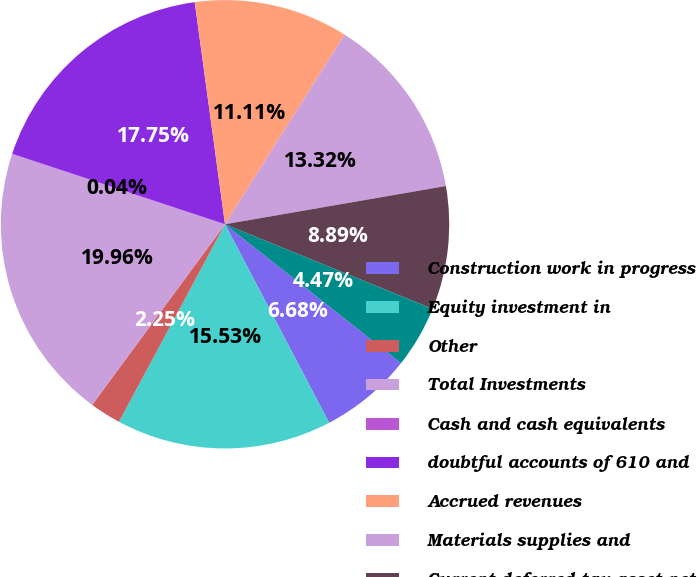Convert chart. <chart><loc_0><loc_0><loc_500><loc_500><pie_chart><fcel>Construction work in progress<fcel>Equity investment in<fcel>Other<fcel>Total Investments<fcel>Cash and cash equivalents<fcel>doubtful accounts of 610 and<fcel>Accrued revenues<fcel>Materials supplies and<fcel>Current deferred tax asset net<fcel>Prepayments<nl><fcel>6.68%<fcel>15.53%<fcel>2.25%<fcel>19.96%<fcel>0.04%<fcel>17.75%<fcel>11.11%<fcel>13.32%<fcel>8.89%<fcel>4.47%<nl></chart> 